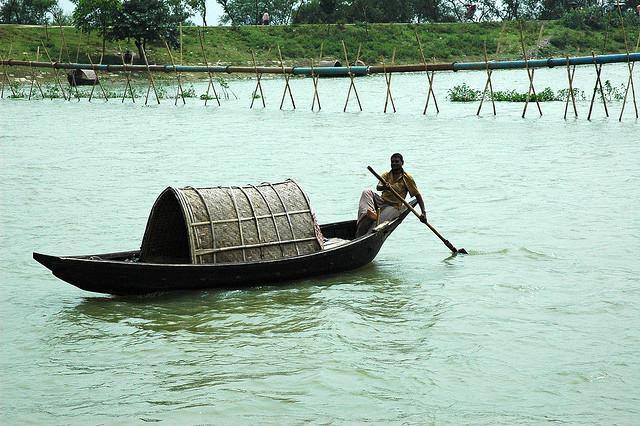How many boats can you see?
Give a very brief answer. 1. How many people are visible?
Give a very brief answer. 1. 